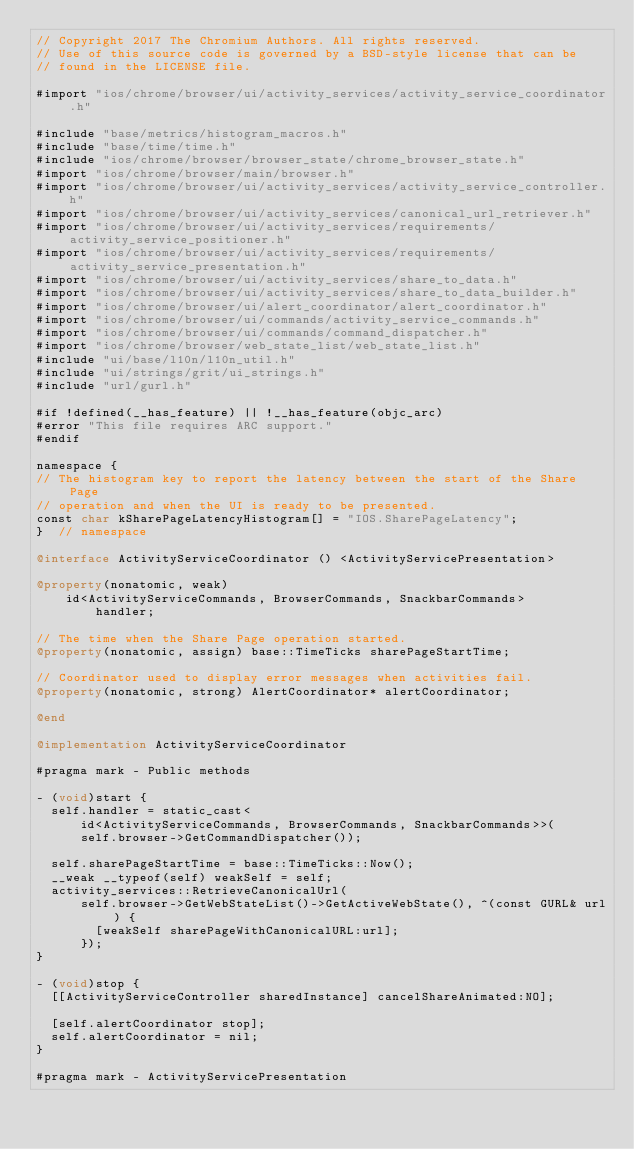<code> <loc_0><loc_0><loc_500><loc_500><_ObjectiveC_>// Copyright 2017 The Chromium Authors. All rights reserved.
// Use of this source code is governed by a BSD-style license that can be
// found in the LICENSE file.

#import "ios/chrome/browser/ui/activity_services/activity_service_coordinator.h"

#include "base/metrics/histogram_macros.h"
#include "base/time/time.h"
#include "ios/chrome/browser/browser_state/chrome_browser_state.h"
#import "ios/chrome/browser/main/browser.h"
#import "ios/chrome/browser/ui/activity_services/activity_service_controller.h"
#import "ios/chrome/browser/ui/activity_services/canonical_url_retriever.h"
#import "ios/chrome/browser/ui/activity_services/requirements/activity_service_positioner.h"
#import "ios/chrome/browser/ui/activity_services/requirements/activity_service_presentation.h"
#import "ios/chrome/browser/ui/activity_services/share_to_data.h"
#import "ios/chrome/browser/ui/activity_services/share_to_data_builder.h"
#import "ios/chrome/browser/ui/alert_coordinator/alert_coordinator.h"
#import "ios/chrome/browser/ui/commands/activity_service_commands.h"
#import "ios/chrome/browser/ui/commands/command_dispatcher.h"
#import "ios/chrome/browser/web_state_list/web_state_list.h"
#include "ui/base/l10n/l10n_util.h"
#include "ui/strings/grit/ui_strings.h"
#include "url/gurl.h"

#if !defined(__has_feature) || !__has_feature(objc_arc)
#error "This file requires ARC support."
#endif

namespace {
// The histogram key to report the latency between the start of the Share Page
// operation and when the UI is ready to be presented.
const char kSharePageLatencyHistogram[] = "IOS.SharePageLatency";
}  // namespace

@interface ActivityServiceCoordinator () <ActivityServicePresentation>

@property(nonatomic, weak)
    id<ActivityServiceCommands, BrowserCommands, SnackbarCommands>
        handler;

// The time when the Share Page operation started.
@property(nonatomic, assign) base::TimeTicks sharePageStartTime;

// Coordinator used to display error messages when activities fail.
@property(nonatomic, strong) AlertCoordinator* alertCoordinator;

@end

@implementation ActivityServiceCoordinator

#pragma mark - Public methods

- (void)start {
  self.handler = static_cast<
      id<ActivityServiceCommands, BrowserCommands, SnackbarCommands>>(
      self.browser->GetCommandDispatcher());

  self.sharePageStartTime = base::TimeTicks::Now();
  __weak __typeof(self) weakSelf = self;
  activity_services::RetrieveCanonicalUrl(
      self.browser->GetWebStateList()->GetActiveWebState(), ^(const GURL& url) {
        [weakSelf sharePageWithCanonicalURL:url];
      });
}

- (void)stop {
  [[ActivityServiceController sharedInstance] cancelShareAnimated:NO];

  [self.alertCoordinator stop];
  self.alertCoordinator = nil;
}

#pragma mark - ActivityServicePresentation
</code> 